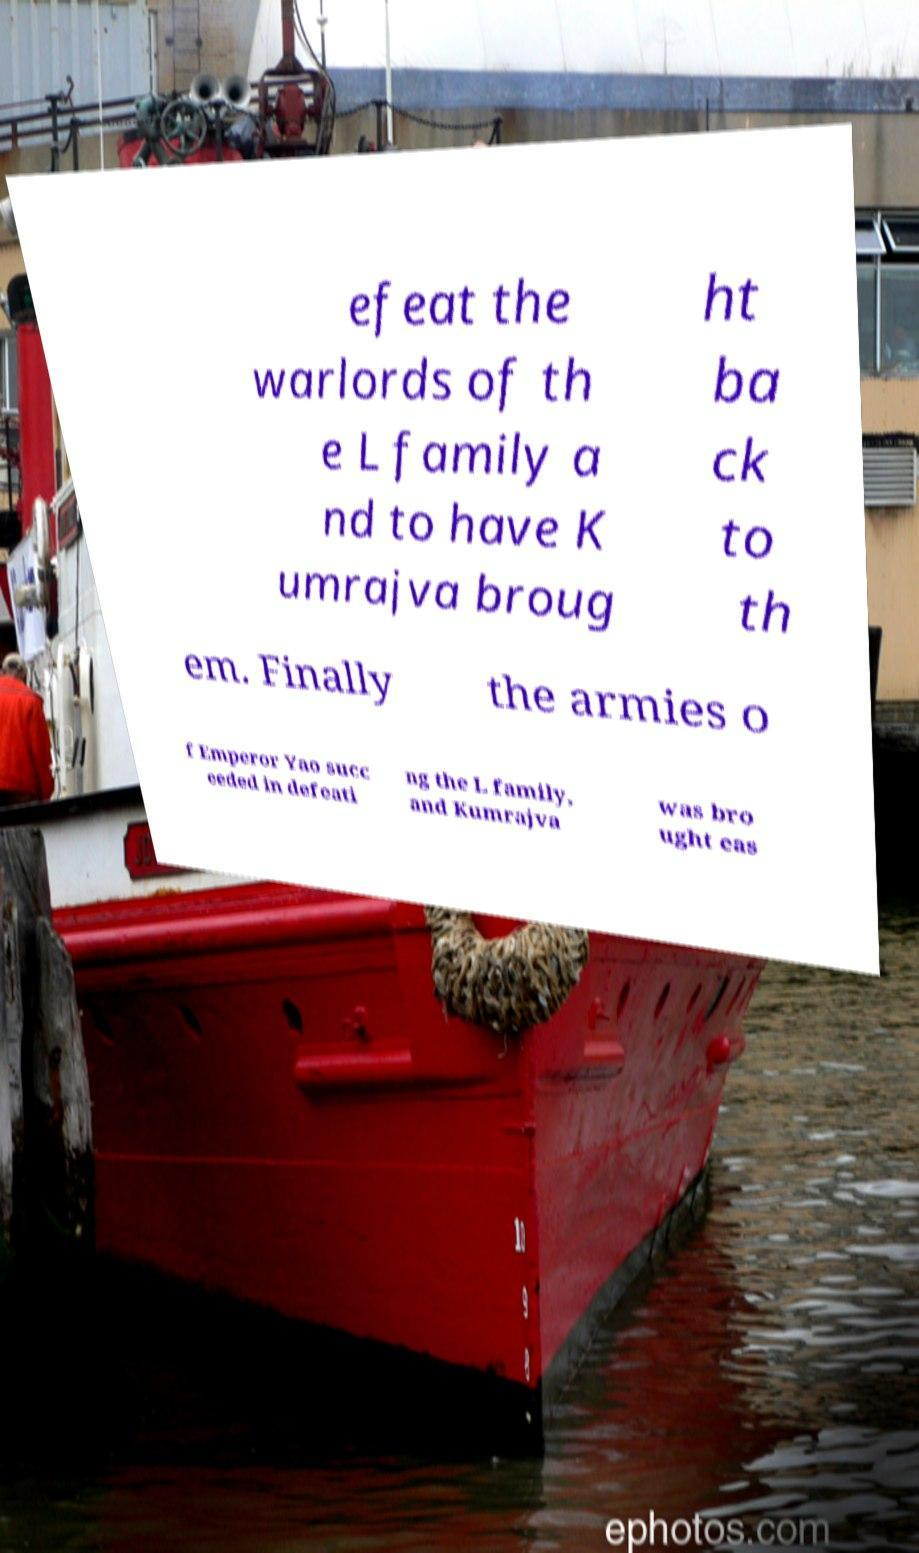There's text embedded in this image that I need extracted. Can you transcribe it verbatim? efeat the warlords of th e L family a nd to have K umrajva broug ht ba ck to th em. Finally the armies o f Emperor Yao succ eeded in defeati ng the L family, and Kumrajva was bro ught eas 